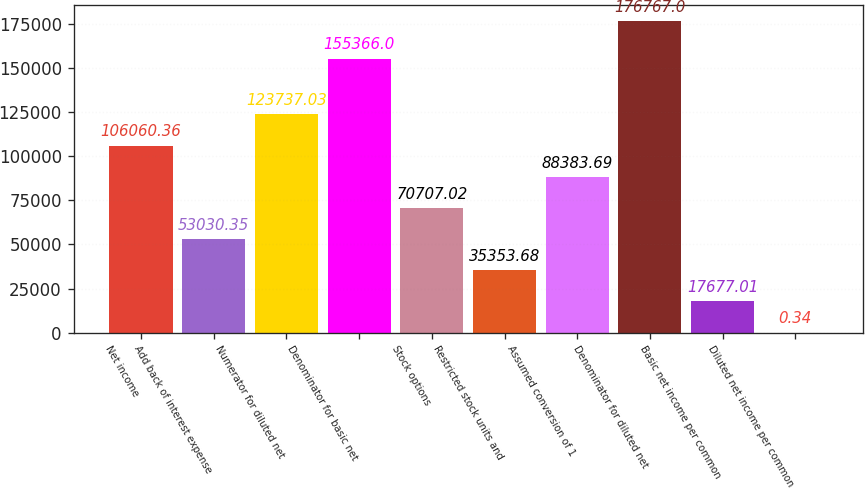Convert chart to OTSL. <chart><loc_0><loc_0><loc_500><loc_500><bar_chart><fcel>Net income<fcel>Add back of interest expense<fcel>Numerator for diluted net<fcel>Denominator for basic net<fcel>Stock options<fcel>Restricted stock units and<fcel>Assumed conversion of 1<fcel>Denominator for diluted net<fcel>Basic net income per common<fcel>Diluted net income per common<nl><fcel>106060<fcel>53030.3<fcel>123737<fcel>155366<fcel>70707<fcel>35353.7<fcel>88383.7<fcel>176767<fcel>17677<fcel>0.34<nl></chart> 